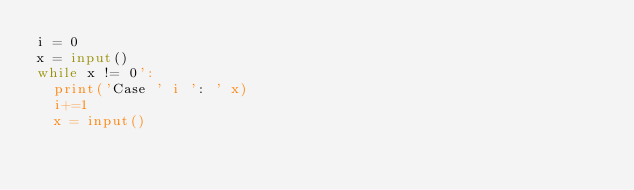Convert code to text. <code><loc_0><loc_0><loc_500><loc_500><_Python_>i = 0
x = input()
while x != 0':
  print('Case ' i ': ' x)
  i+=1
  x = input()
</code> 